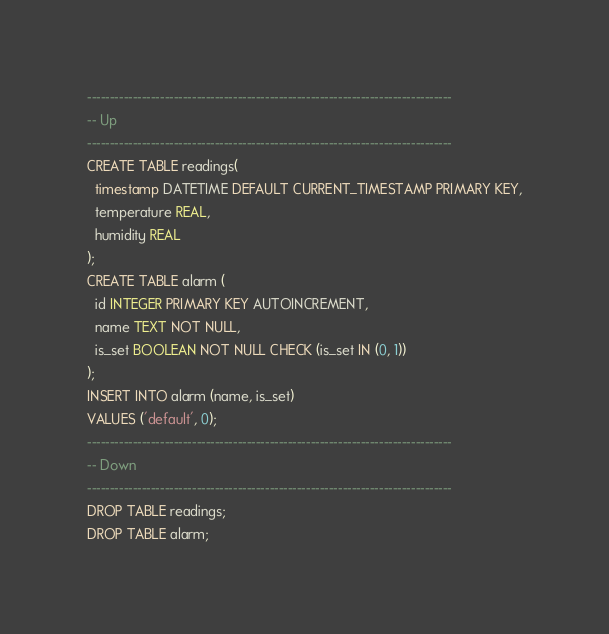Convert code to text. <code><loc_0><loc_0><loc_500><loc_500><_SQL_>--------------------------------------------------------------------------------
-- Up
--------------------------------------------------------------------------------
CREATE TABLE readings(
  timestamp DATETIME DEFAULT CURRENT_TIMESTAMP PRIMARY KEY,
  temperature REAL,
  humidity REAL
);
CREATE TABLE alarm (
  id INTEGER PRIMARY KEY AUTOINCREMENT,
  name TEXT NOT NULL,
  is_set BOOLEAN NOT NULL CHECK (is_set IN (0, 1))
);
INSERT INTO alarm (name, is_set)
VALUES ('default', 0);
--------------------------------------------------------------------------------
-- Down
--------------------------------------------------------------------------------
DROP TABLE readings;
DROP TABLE alarm;
</code> 